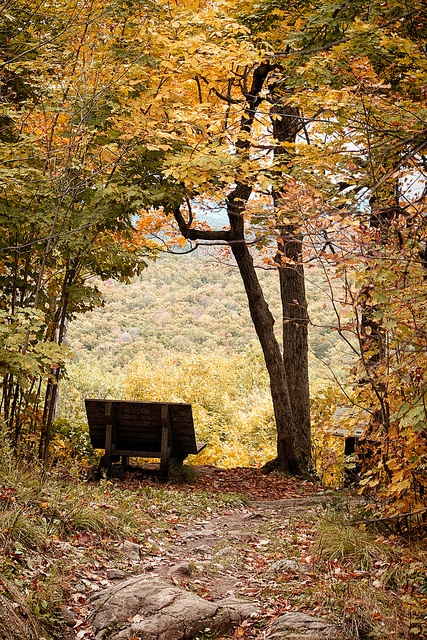Describe the objects in this image and their specific colors. I can see a bench in gray, black, maroon, and olive tones in this image. 